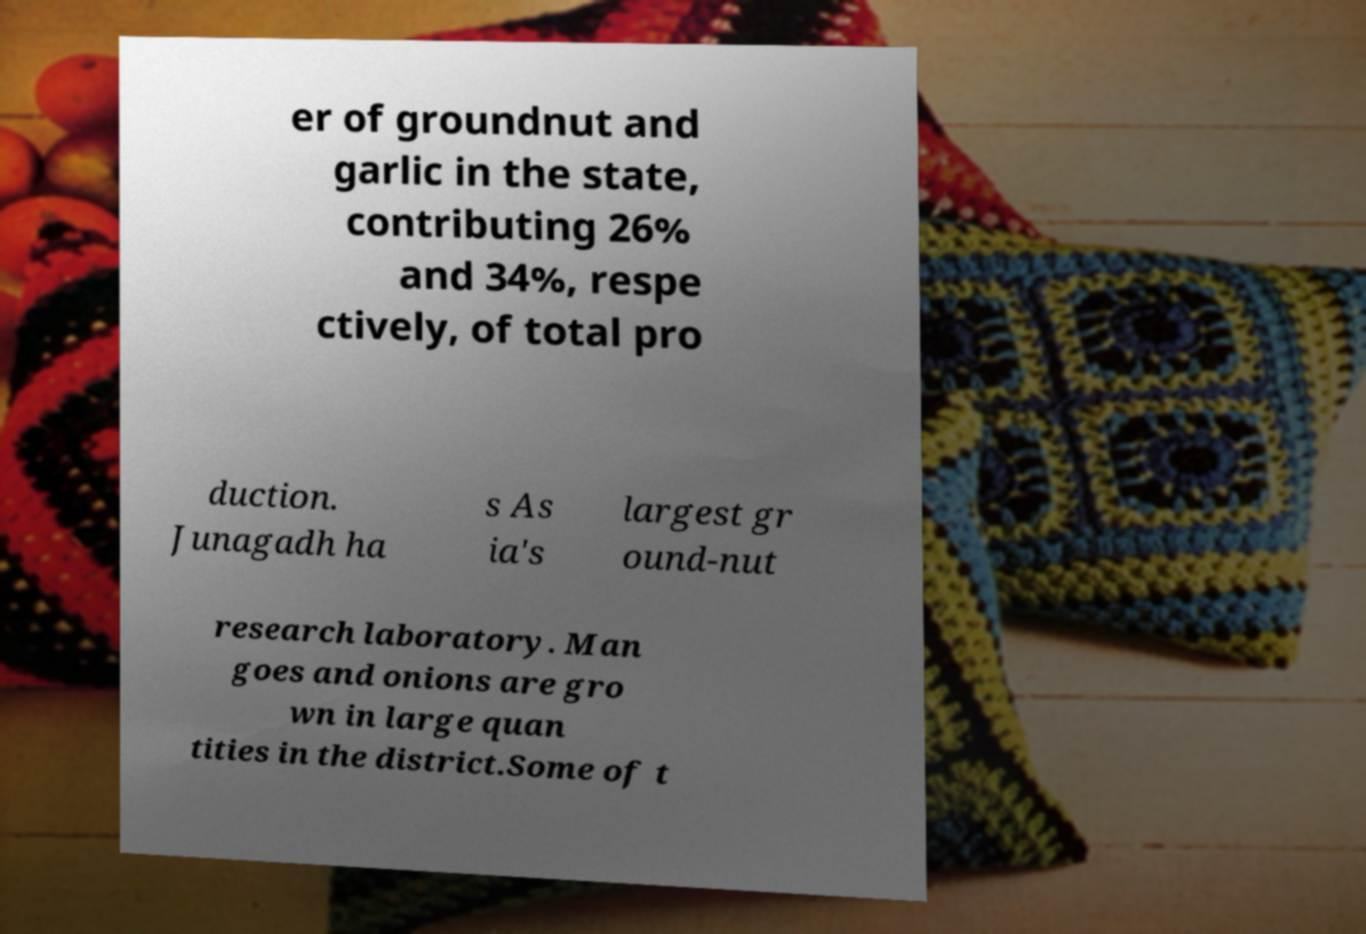Could you extract and type out the text from this image? er of groundnut and garlic in the state, contributing 26% and 34%, respe ctively, of total pro duction. Junagadh ha s As ia's largest gr ound-nut research laboratory. Man goes and onions are gro wn in large quan tities in the district.Some of t 